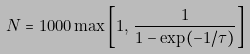Convert formula to latex. <formula><loc_0><loc_0><loc_500><loc_500>N = 1 0 0 0 \max \left [ 1 , \, \frac { 1 } { 1 - \exp ( - 1 / \tau ) } \right ]</formula> 